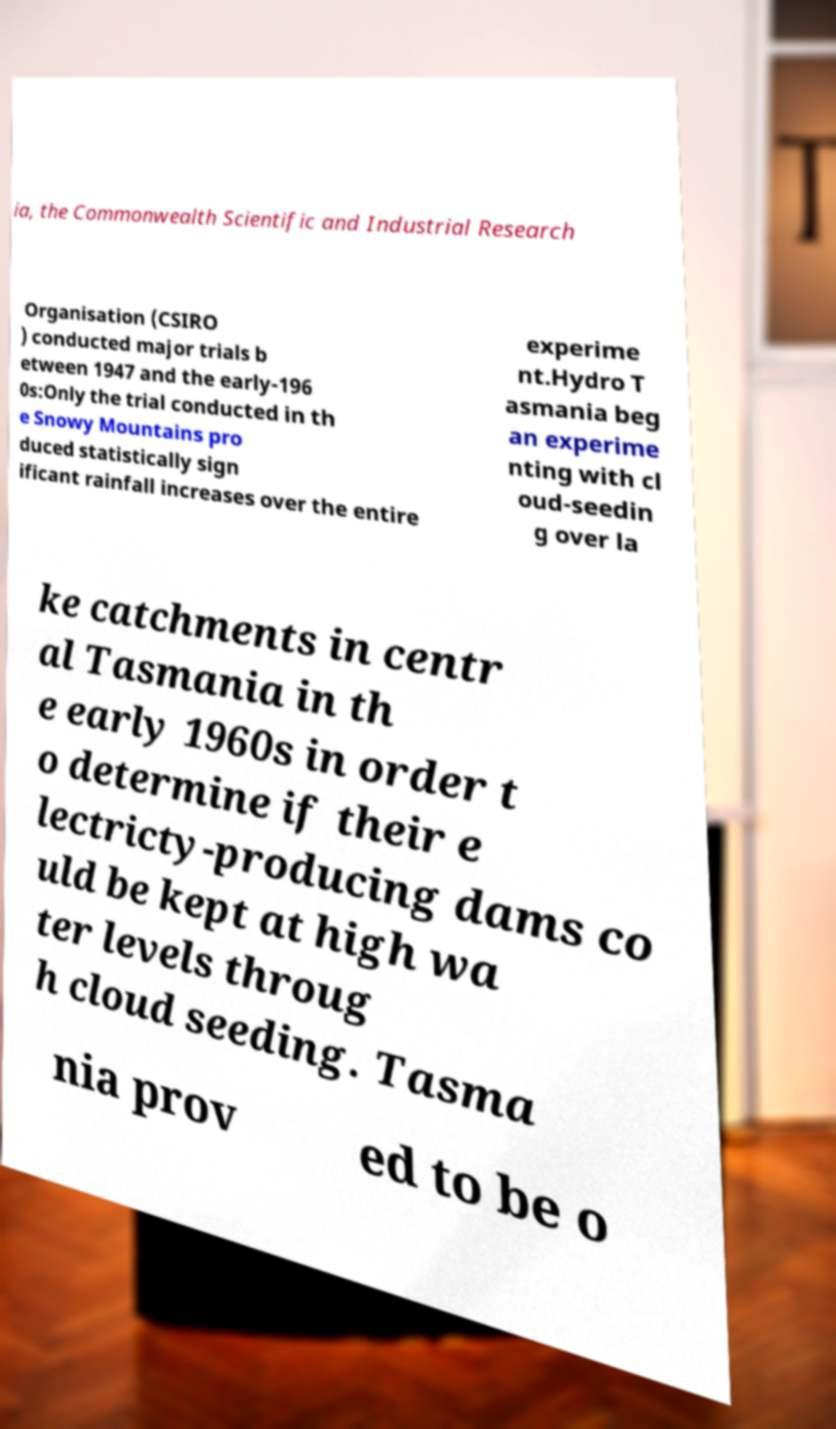What messages or text are displayed in this image? I need them in a readable, typed format. ia, the Commonwealth Scientific and Industrial Research Organisation (CSIRO ) conducted major trials b etween 1947 and the early-196 0s:Only the trial conducted in th e Snowy Mountains pro duced statistically sign ificant rainfall increases over the entire experime nt.Hydro T asmania beg an experime nting with cl oud-seedin g over la ke catchments in centr al Tasmania in th e early 1960s in order t o determine if their e lectricty-producing dams co uld be kept at high wa ter levels throug h cloud seeding. Tasma nia prov ed to be o 